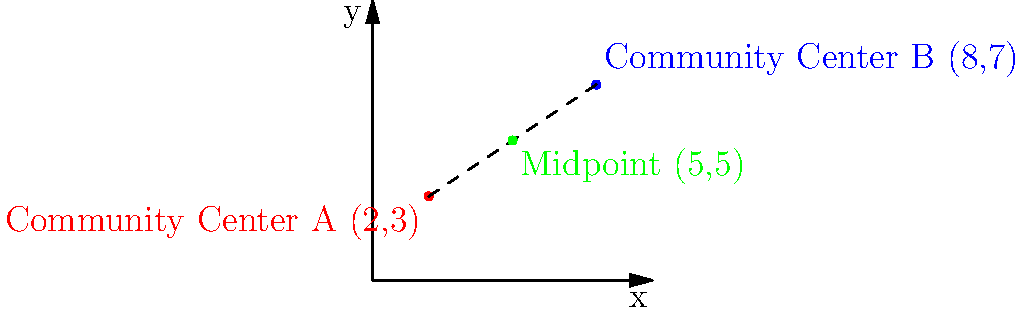As the friendly neighbor organizing a community event, you're trying to find a location equidistant from two community centers. Community Center A is located at (2,3) and Community Center B is at (8,7) on the city grid. What are the coordinates of the midpoint between these two centers, where you could potentially host the event? To find the midpoint between two points, we use the midpoint formula:

$$ \text{Midpoint} = (\frac{x_1 + x_2}{2}, \frac{y_1 + y_2}{2}) $$

Where $(x_1, y_1)$ are the coordinates of the first point and $(x_2, y_2)$ are the coordinates of the second point.

For our community centers:
1. Community Center A: $(x_1, y_1) = (2, 3)$
2. Community Center B: $(x_2, y_2) = (8, 7)$

Let's calculate the x-coordinate of the midpoint:
$$ x = \frac{x_1 + x_2}{2} = \frac{2 + 8}{2} = \frac{10}{2} = 5 $$

Now, let's calculate the y-coordinate of the midpoint:
$$ y = \frac{y_1 + y_2}{2} = \frac{3 + 7}{2} = \frac{10}{2} = 5 $$

Therefore, the midpoint between the two community centers is (5, 5).
Answer: (5, 5) 